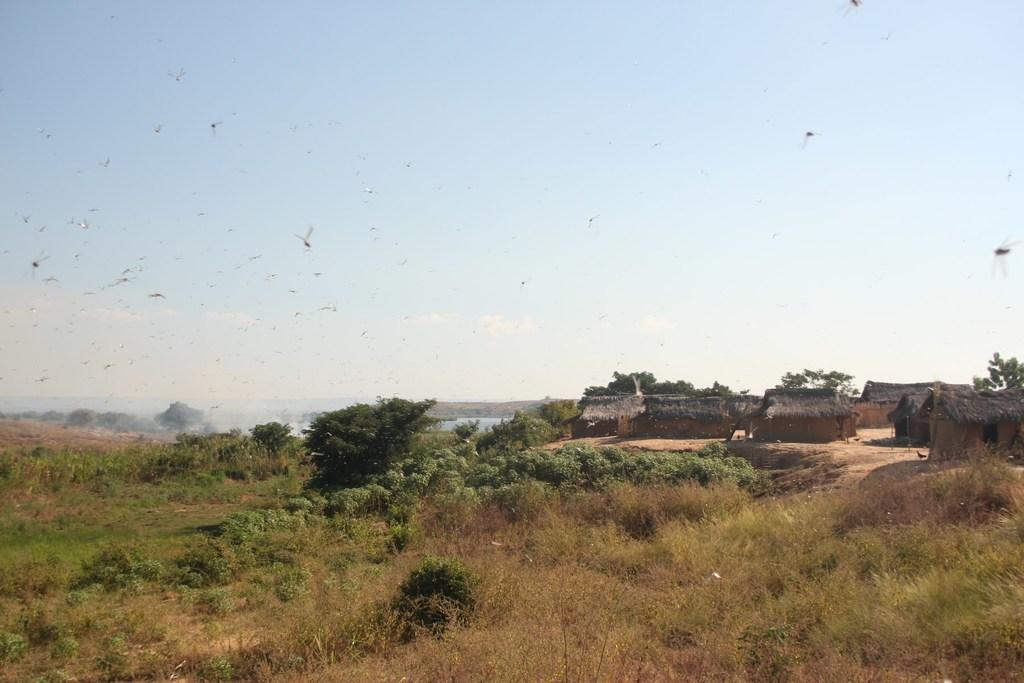What type of structures are present in the image? There are huts in the image. What type of vegetation can be seen in the image? There are trees and plants in the image. What is the ground covered with in the image? The ground is covered with grass in the image. What type of insects are visible in the image? Flies are visible in the image. What is the color and condition of the sky in the image? The sky is blue and cloudy in the image. What type of stew is being prepared in the image? There is no stew being prepared in the image; it features huts, trees, plants, grass, flies, and a blue and cloudy sky. What invention is being used to care for the plants in the image? There is no specific invention mentioned or depicted in the image; it simply shows plants in their natural environment. 